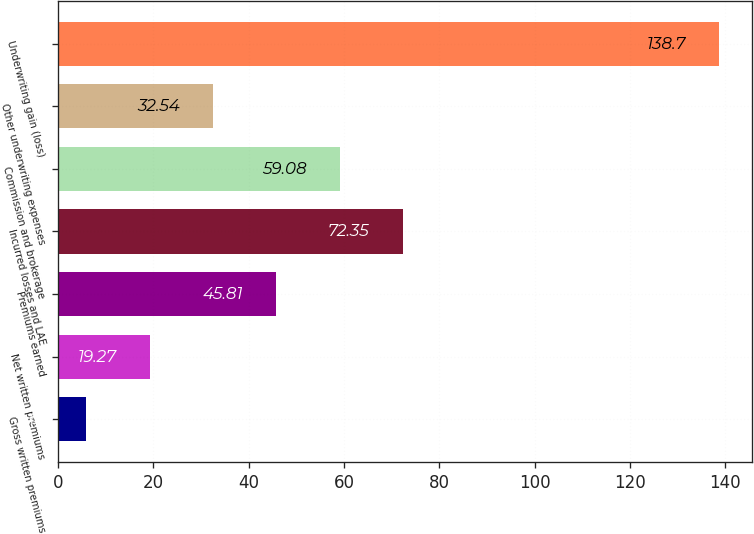Convert chart to OTSL. <chart><loc_0><loc_0><loc_500><loc_500><bar_chart><fcel>Gross written premiums<fcel>Net written premiums<fcel>Premiums earned<fcel>Incurred losses and LAE<fcel>Commission and brokerage<fcel>Other underwriting expenses<fcel>Underwriting gain (loss)<nl><fcel>6<fcel>19.27<fcel>45.81<fcel>72.35<fcel>59.08<fcel>32.54<fcel>138.7<nl></chart> 